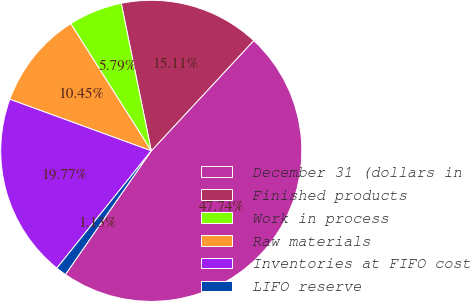Convert chart. <chart><loc_0><loc_0><loc_500><loc_500><pie_chart><fcel>December 31 (dollars in<fcel>Finished products<fcel>Work in process<fcel>Raw materials<fcel>Inventories at FIFO cost<fcel>LIFO reserve<nl><fcel>47.74%<fcel>15.11%<fcel>5.79%<fcel>10.45%<fcel>19.77%<fcel>1.13%<nl></chart> 